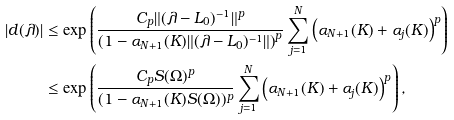<formula> <loc_0><loc_0><loc_500><loc_500>| d ( \lambda ) | & \leq \exp \left ( \frac { C _ { p } \| ( \lambda - L _ { 0 } ) ^ { - 1 } \| ^ { p } } { \left ( 1 - \alpha _ { N + 1 } ( K ) \| ( \lambda - L _ { 0 } ) ^ { - 1 } \| \right ) ^ { p } } \sum _ { j = 1 } ^ { N } \left ( \alpha _ { N + 1 } ( K ) + \alpha _ { j } ( K ) \right ) ^ { p } \right ) \\ & \leq \exp \left ( \frac { C _ { p } S ( \Omega ) ^ { p } } { ( 1 - \alpha _ { N + 1 } ( K ) S ( \Omega ) ) ^ { p } } \sum _ { j = 1 } ^ { N } \left ( \alpha _ { N + 1 } ( K ) + \alpha _ { j } ( K ) \right ) ^ { p } \right ) ,</formula> 